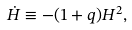Convert formula to latex. <formula><loc_0><loc_0><loc_500><loc_500>\dot { H } \equiv - ( 1 + q ) H ^ { 2 } ,</formula> 